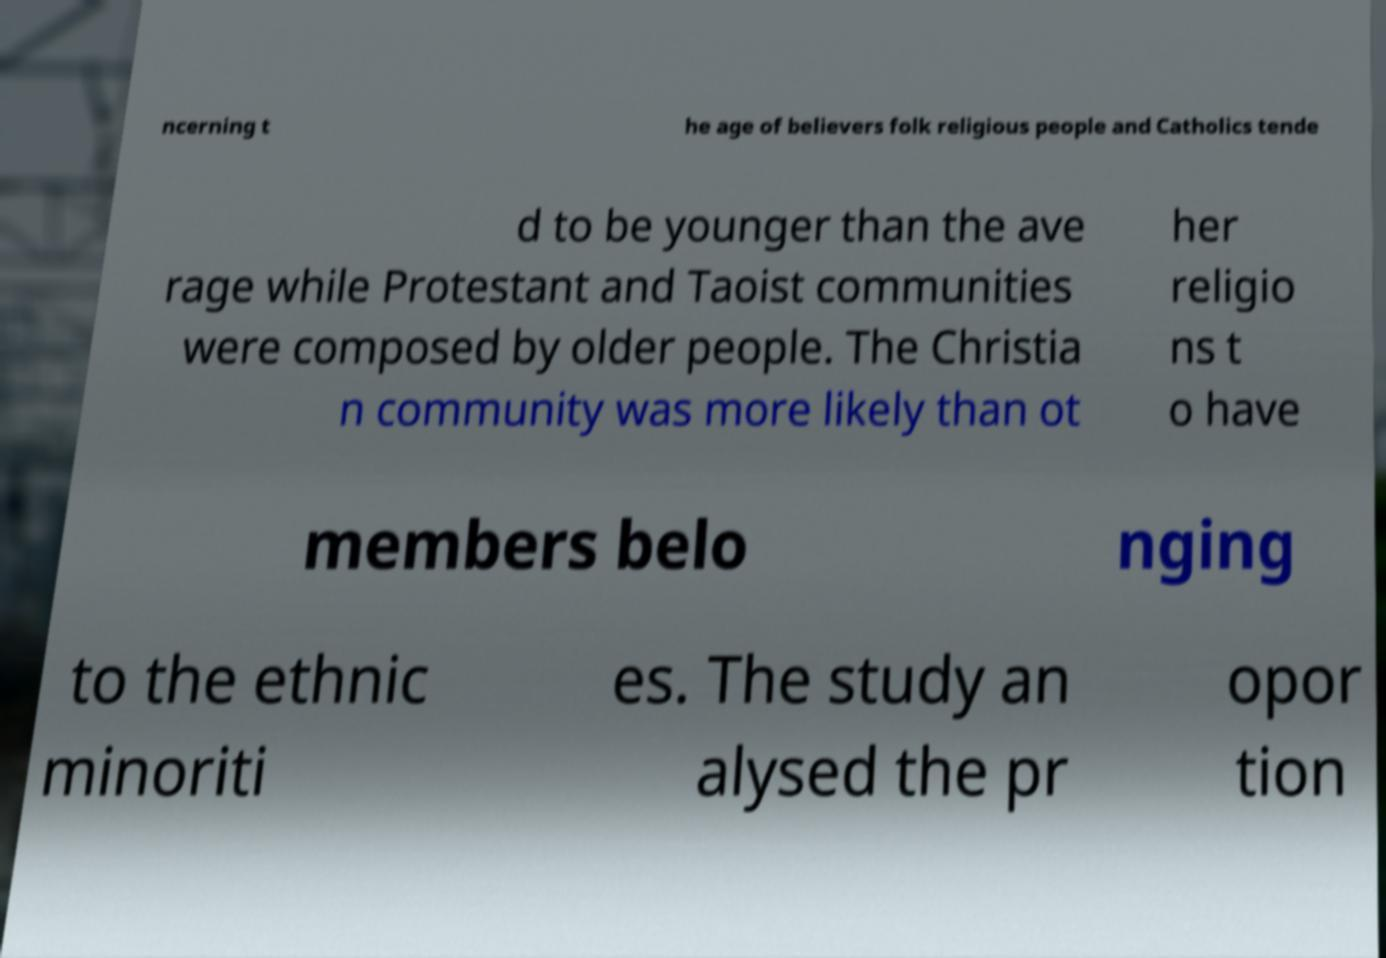Can you read and provide the text displayed in the image?This photo seems to have some interesting text. Can you extract and type it out for me? ncerning t he age of believers folk religious people and Catholics tende d to be younger than the ave rage while Protestant and Taoist communities were composed by older people. The Christia n community was more likely than ot her religio ns t o have members belo nging to the ethnic minoriti es. The study an alysed the pr opor tion 